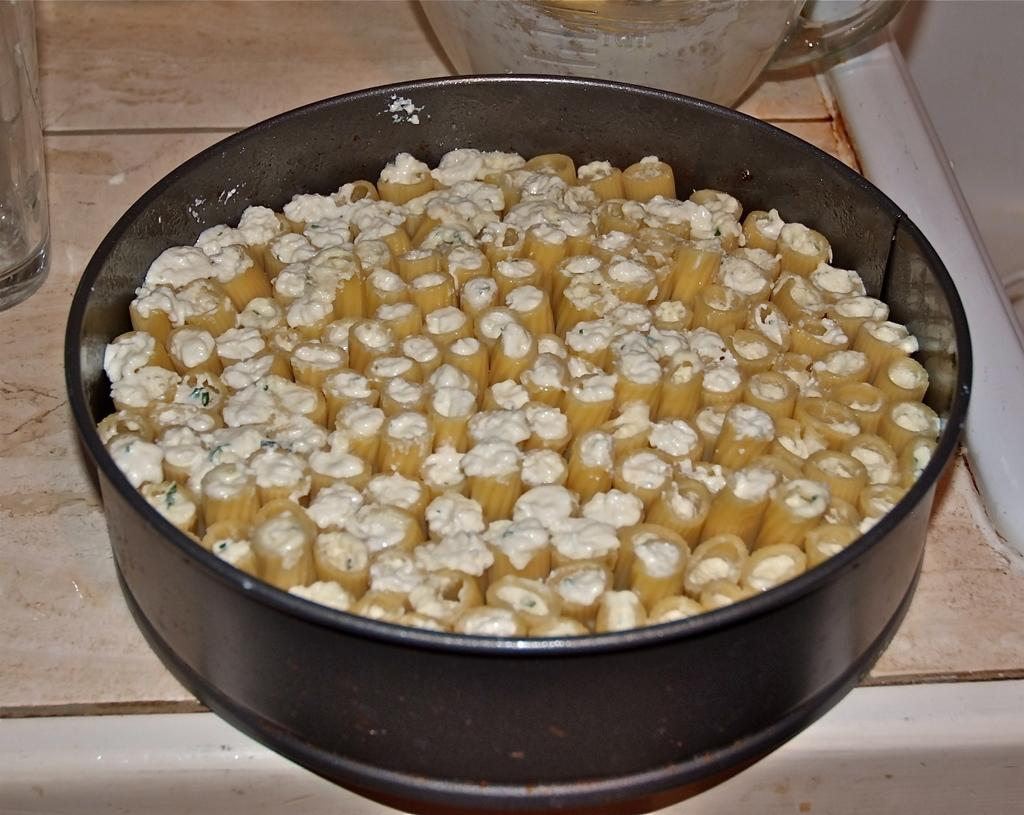What is the color of the container in the image? The container in the image is black. What is the material of the surface where the glass is placed? The surface where the glass is placed is wooden. How many bikes are parked next to the container in the image? There are no bikes present in the image. What is the price of the glass in the image? The price of the glass is not mentioned in the image. --- Facts: 1. There is a person holding a book in the image. 2. The person is sitting on a chair. 3. There is a table next to the chair. 4. The book has a red cover. Absurd Topics: elephant, ocean, parachute Conversation: What is the person in the image holding? The person in the image is holding a book. What is the person's seating arrangement in the image? The person is sitting on a chair. What is located next to the chair in the image? There is a table next to the chair. What is the color of the book cover in the image? The book cover in the image is red. Reasoning: Let's think step by step in order to produce the conversation. We start by identifying the main subject in the image, which is the person holding a book. Then, we expand the conversation to include the person's seating arrangement and the presence of a table next to the chair. Finally, we describe the color of the book cover, which is red. Each question is designed to elicit a specific detail about the image that is known from the provided facts. Absurd Question/Answer: Can you see an elephant swimming in the ocean in the image? No, there is no elephant or ocean present in the image. Is the person in the image wearing a parachute? There is no mention or indication of a parachute in the image. 